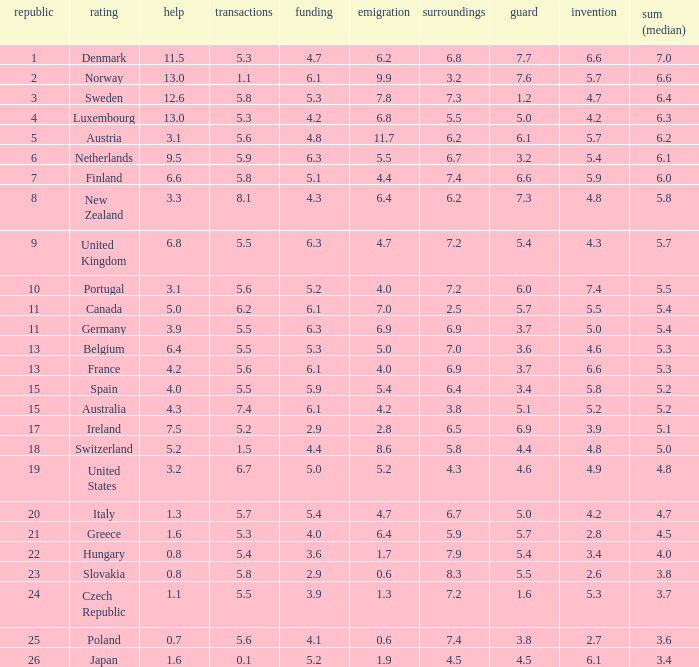What is the environment rating of the country with an overall average rating of 4.7? 6.7. 